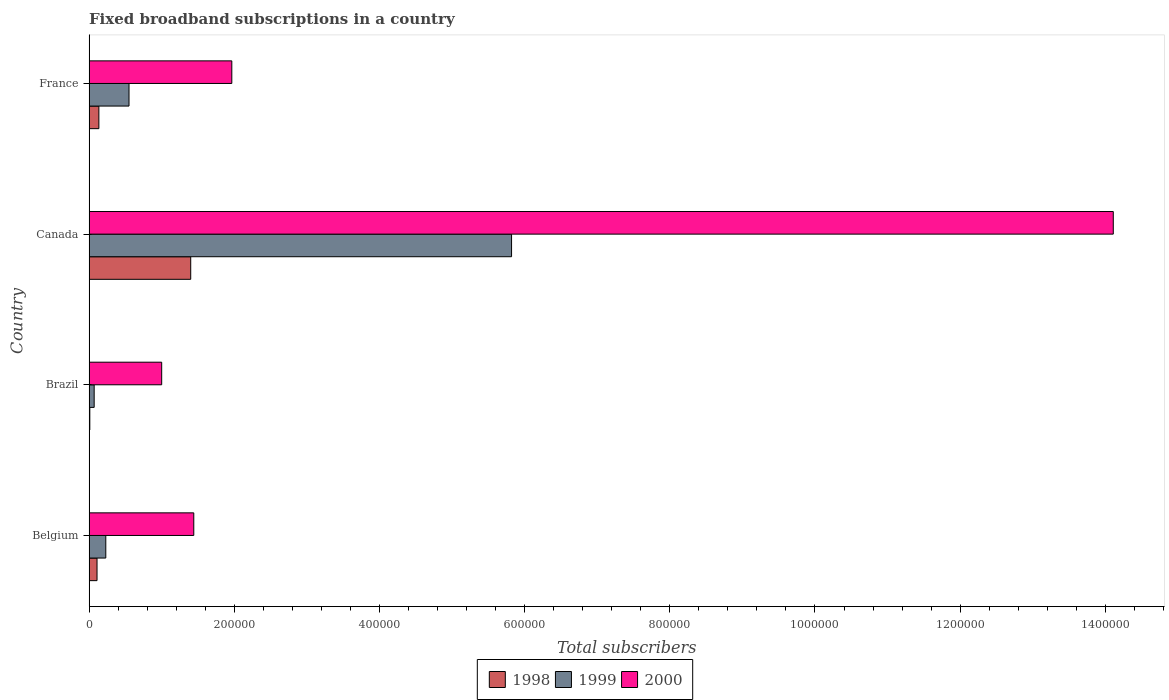How many different coloured bars are there?
Keep it short and to the point. 3. Are the number of bars per tick equal to the number of legend labels?
Offer a terse response. Yes. Are the number of bars on each tick of the Y-axis equal?
Your response must be concise. Yes. In how many cases, is the number of bars for a given country not equal to the number of legend labels?
Ensure brevity in your answer.  0. What is the number of broadband subscriptions in 1999 in Belgium?
Make the answer very short. 2.30e+04. Across all countries, what is the maximum number of broadband subscriptions in 1999?
Offer a terse response. 5.82e+05. Across all countries, what is the minimum number of broadband subscriptions in 1999?
Give a very brief answer. 7000. In which country was the number of broadband subscriptions in 1999 minimum?
Provide a short and direct response. Brazil. What is the total number of broadband subscriptions in 2000 in the graph?
Your answer should be very brief. 1.85e+06. What is the difference between the number of broadband subscriptions in 1999 in Belgium and that in Brazil?
Your answer should be very brief. 1.60e+04. What is the difference between the number of broadband subscriptions in 2000 in Canada and the number of broadband subscriptions in 1998 in Belgium?
Offer a terse response. 1.40e+06. What is the average number of broadband subscriptions in 1998 per country?
Your answer should be very brief. 4.13e+04. What is the difference between the number of broadband subscriptions in 2000 and number of broadband subscriptions in 1999 in France?
Make the answer very short. 1.42e+05. In how many countries, is the number of broadband subscriptions in 1999 greater than 800000 ?
Keep it short and to the point. 0. What is the ratio of the number of broadband subscriptions in 2000 in Brazil to that in Canada?
Ensure brevity in your answer.  0.07. Is the difference between the number of broadband subscriptions in 2000 in Brazil and Canada greater than the difference between the number of broadband subscriptions in 1999 in Brazil and Canada?
Offer a very short reply. No. What is the difference between the highest and the second highest number of broadband subscriptions in 1999?
Provide a succinct answer. 5.27e+05. What is the difference between the highest and the lowest number of broadband subscriptions in 1999?
Make the answer very short. 5.75e+05. What does the 1st bar from the top in Belgium represents?
Your response must be concise. 2000. How many bars are there?
Give a very brief answer. 12. Are all the bars in the graph horizontal?
Your answer should be very brief. Yes. Are the values on the major ticks of X-axis written in scientific E-notation?
Offer a very short reply. No. Does the graph contain any zero values?
Your answer should be very brief. No. Where does the legend appear in the graph?
Your response must be concise. Bottom center. How are the legend labels stacked?
Your answer should be compact. Horizontal. What is the title of the graph?
Your answer should be very brief. Fixed broadband subscriptions in a country. Does "2002" appear as one of the legend labels in the graph?
Your answer should be very brief. No. What is the label or title of the X-axis?
Your answer should be compact. Total subscribers. What is the label or title of the Y-axis?
Ensure brevity in your answer.  Country. What is the Total subscribers in 1998 in Belgium?
Give a very brief answer. 1.09e+04. What is the Total subscribers of 1999 in Belgium?
Offer a terse response. 2.30e+04. What is the Total subscribers in 2000 in Belgium?
Ensure brevity in your answer.  1.44e+05. What is the Total subscribers in 1998 in Brazil?
Your response must be concise. 1000. What is the Total subscribers of 1999 in Brazil?
Give a very brief answer. 7000. What is the Total subscribers of 2000 in Brazil?
Provide a succinct answer. 1.00e+05. What is the Total subscribers in 1998 in Canada?
Give a very brief answer. 1.40e+05. What is the Total subscribers in 1999 in Canada?
Ensure brevity in your answer.  5.82e+05. What is the Total subscribers in 2000 in Canada?
Provide a short and direct response. 1.41e+06. What is the Total subscribers of 1998 in France?
Offer a very short reply. 1.35e+04. What is the Total subscribers of 1999 in France?
Keep it short and to the point. 5.50e+04. What is the Total subscribers of 2000 in France?
Make the answer very short. 1.97e+05. Across all countries, what is the maximum Total subscribers of 1999?
Your response must be concise. 5.82e+05. Across all countries, what is the maximum Total subscribers in 2000?
Your answer should be compact. 1.41e+06. Across all countries, what is the minimum Total subscribers in 1999?
Your response must be concise. 7000. What is the total Total subscribers of 1998 in the graph?
Provide a succinct answer. 1.65e+05. What is the total Total subscribers in 1999 in the graph?
Keep it short and to the point. 6.67e+05. What is the total Total subscribers of 2000 in the graph?
Keep it short and to the point. 1.85e+06. What is the difference between the Total subscribers in 1998 in Belgium and that in Brazil?
Offer a terse response. 9924. What is the difference between the Total subscribers in 1999 in Belgium and that in Brazil?
Offer a very short reply. 1.60e+04. What is the difference between the Total subscribers of 2000 in Belgium and that in Brazil?
Give a very brief answer. 4.42e+04. What is the difference between the Total subscribers in 1998 in Belgium and that in Canada?
Provide a short and direct response. -1.29e+05. What is the difference between the Total subscribers of 1999 in Belgium and that in Canada?
Your response must be concise. -5.59e+05. What is the difference between the Total subscribers in 2000 in Belgium and that in Canada?
Ensure brevity in your answer.  -1.27e+06. What is the difference between the Total subscribers of 1998 in Belgium and that in France?
Keep it short and to the point. -2540. What is the difference between the Total subscribers in 1999 in Belgium and that in France?
Keep it short and to the point. -3.20e+04. What is the difference between the Total subscribers of 2000 in Belgium and that in France?
Provide a succinct answer. -5.24e+04. What is the difference between the Total subscribers in 1998 in Brazil and that in Canada?
Provide a succinct answer. -1.39e+05. What is the difference between the Total subscribers in 1999 in Brazil and that in Canada?
Provide a short and direct response. -5.75e+05. What is the difference between the Total subscribers in 2000 in Brazil and that in Canada?
Offer a very short reply. -1.31e+06. What is the difference between the Total subscribers of 1998 in Brazil and that in France?
Provide a short and direct response. -1.25e+04. What is the difference between the Total subscribers in 1999 in Brazil and that in France?
Give a very brief answer. -4.80e+04. What is the difference between the Total subscribers in 2000 in Brazil and that in France?
Make the answer very short. -9.66e+04. What is the difference between the Total subscribers of 1998 in Canada and that in France?
Provide a short and direct response. 1.27e+05. What is the difference between the Total subscribers in 1999 in Canada and that in France?
Offer a very short reply. 5.27e+05. What is the difference between the Total subscribers of 2000 in Canada and that in France?
Give a very brief answer. 1.21e+06. What is the difference between the Total subscribers of 1998 in Belgium and the Total subscribers of 1999 in Brazil?
Offer a very short reply. 3924. What is the difference between the Total subscribers in 1998 in Belgium and the Total subscribers in 2000 in Brazil?
Give a very brief answer. -8.91e+04. What is the difference between the Total subscribers of 1999 in Belgium and the Total subscribers of 2000 in Brazil?
Ensure brevity in your answer.  -7.70e+04. What is the difference between the Total subscribers in 1998 in Belgium and the Total subscribers in 1999 in Canada?
Provide a short and direct response. -5.71e+05. What is the difference between the Total subscribers in 1998 in Belgium and the Total subscribers in 2000 in Canada?
Give a very brief answer. -1.40e+06. What is the difference between the Total subscribers of 1999 in Belgium and the Total subscribers of 2000 in Canada?
Keep it short and to the point. -1.39e+06. What is the difference between the Total subscribers of 1998 in Belgium and the Total subscribers of 1999 in France?
Your response must be concise. -4.41e+04. What is the difference between the Total subscribers of 1998 in Belgium and the Total subscribers of 2000 in France?
Your answer should be very brief. -1.86e+05. What is the difference between the Total subscribers in 1999 in Belgium and the Total subscribers in 2000 in France?
Ensure brevity in your answer.  -1.74e+05. What is the difference between the Total subscribers in 1998 in Brazil and the Total subscribers in 1999 in Canada?
Your answer should be compact. -5.81e+05. What is the difference between the Total subscribers of 1998 in Brazil and the Total subscribers of 2000 in Canada?
Offer a very short reply. -1.41e+06. What is the difference between the Total subscribers in 1999 in Brazil and the Total subscribers in 2000 in Canada?
Your answer should be compact. -1.40e+06. What is the difference between the Total subscribers in 1998 in Brazil and the Total subscribers in 1999 in France?
Make the answer very short. -5.40e+04. What is the difference between the Total subscribers of 1998 in Brazil and the Total subscribers of 2000 in France?
Your answer should be very brief. -1.96e+05. What is the difference between the Total subscribers of 1999 in Brazil and the Total subscribers of 2000 in France?
Your answer should be very brief. -1.90e+05. What is the difference between the Total subscribers of 1998 in Canada and the Total subscribers of 1999 in France?
Provide a short and direct response. 8.50e+04. What is the difference between the Total subscribers of 1998 in Canada and the Total subscribers of 2000 in France?
Your answer should be very brief. -5.66e+04. What is the difference between the Total subscribers in 1999 in Canada and the Total subscribers in 2000 in France?
Provide a short and direct response. 3.85e+05. What is the average Total subscribers of 1998 per country?
Keep it short and to the point. 4.13e+04. What is the average Total subscribers of 1999 per country?
Your answer should be compact. 1.67e+05. What is the average Total subscribers of 2000 per country?
Provide a succinct answer. 4.63e+05. What is the difference between the Total subscribers of 1998 and Total subscribers of 1999 in Belgium?
Give a very brief answer. -1.21e+04. What is the difference between the Total subscribers in 1998 and Total subscribers in 2000 in Belgium?
Your answer should be very brief. -1.33e+05. What is the difference between the Total subscribers of 1999 and Total subscribers of 2000 in Belgium?
Your answer should be compact. -1.21e+05. What is the difference between the Total subscribers in 1998 and Total subscribers in 1999 in Brazil?
Give a very brief answer. -6000. What is the difference between the Total subscribers in 1998 and Total subscribers in 2000 in Brazil?
Offer a terse response. -9.90e+04. What is the difference between the Total subscribers in 1999 and Total subscribers in 2000 in Brazil?
Your answer should be very brief. -9.30e+04. What is the difference between the Total subscribers of 1998 and Total subscribers of 1999 in Canada?
Give a very brief answer. -4.42e+05. What is the difference between the Total subscribers of 1998 and Total subscribers of 2000 in Canada?
Offer a terse response. -1.27e+06. What is the difference between the Total subscribers in 1999 and Total subscribers in 2000 in Canada?
Provide a short and direct response. -8.29e+05. What is the difference between the Total subscribers in 1998 and Total subscribers in 1999 in France?
Give a very brief answer. -4.15e+04. What is the difference between the Total subscribers in 1998 and Total subscribers in 2000 in France?
Provide a short and direct response. -1.83e+05. What is the difference between the Total subscribers in 1999 and Total subscribers in 2000 in France?
Provide a short and direct response. -1.42e+05. What is the ratio of the Total subscribers in 1998 in Belgium to that in Brazil?
Your answer should be very brief. 10.92. What is the ratio of the Total subscribers in 1999 in Belgium to that in Brazil?
Give a very brief answer. 3.29. What is the ratio of the Total subscribers of 2000 in Belgium to that in Brazil?
Offer a very short reply. 1.44. What is the ratio of the Total subscribers of 1998 in Belgium to that in Canada?
Keep it short and to the point. 0.08. What is the ratio of the Total subscribers in 1999 in Belgium to that in Canada?
Keep it short and to the point. 0.04. What is the ratio of the Total subscribers in 2000 in Belgium to that in Canada?
Give a very brief answer. 0.1. What is the ratio of the Total subscribers in 1998 in Belgium to that in France?
Your response must be concise. 0.81. What is the ratio of the Total subscribers in 1999 in Belgium to that in France?
Offer a terse response. 0.42. What is the ratio of the Total subscribers of 2000 in Belgium to that in France?
Your answer should be compact. 0.73. What is the ratio of the Total subscribers in 1998 in Brazil to that in Canada?
Your answer should be very brief. 0.01. What is the ratio of the Total subscribers in 1999 in Brazil to that in Canada?
Give a very brief answer. 0.01. What is the ratio of the Total subscribers of 2000 in Brazil to that in Canada?
Provide a short and direct response. 0.07. What is the ratio of the Total subscribers in 1998 in Brazil to that in France?
Provide a succinct answer. 0.07. What is the ratio of the Total subscribers of 1999 in Brazil to that in France?
Give a very brief answer. 0.13. What is the ratio of the Total subscribers of 2000 in Brazil to that in France?
Make the answer very short. 0.51. What is the ratio of the Total subscribers in 1998 in Canada to that in France?
Offer a very short reply. 10.4. What is the ratio of the Total subscribers in 1999 in Canada to that in France?
Your answer should be compact. 10.58. What is the ratio of the Total subscribers in 2000 in Canada to that in France?
Ensure brevity in your answer.  7.18. What is the difference between the highest and the second highest Total subscribers of 1998?
Make the answer very short. 1.27e+05. What is the difference between the highest and the second highest Total subscribers in 1999?
Give a very brief answer. 5.27e+05. What is the difference between the highest and the second highest Total subscribers of 2000?
Your answer should be compact. 1.21e+06. What is the difference between the highest and the lowest Total subscribers of 1998?
Provide a succinct answer. 1.39e+05. What is the difference between the highest and the lowest Total subscribers in 1999?
Your response must be concise. 5.75e+05. What is the difference between the highest and the lowest Total subscribers in 2000?
Provide a short and direct response. 1.31e+06. 